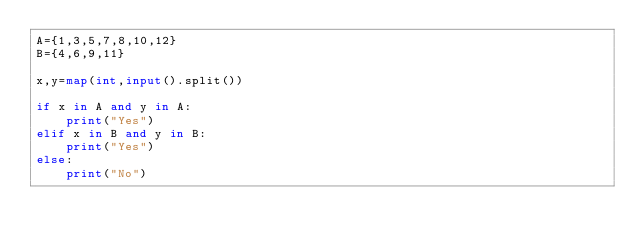<code> <loc_0><loc_0><loc_500><loc_500><_Python_>A={1,3,5,7,8,10,12}
B={4,6,9,11}

x,y=map(int,input().split())

if x in A and y in A:
    print("Yes")
elif x in B and y in B:
    print("Yes")
else:
    print("No")
</code> 